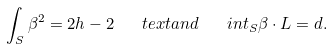Convert formula to latex. <formula><loc_0><loc_0><loc_500><loc_500>\int _ { S } \beta ^ { 2 } = 2 h - 2 \quad t e x t { a n d } \quad i n t _ { S } \beta \cdot L = d .</formula> 